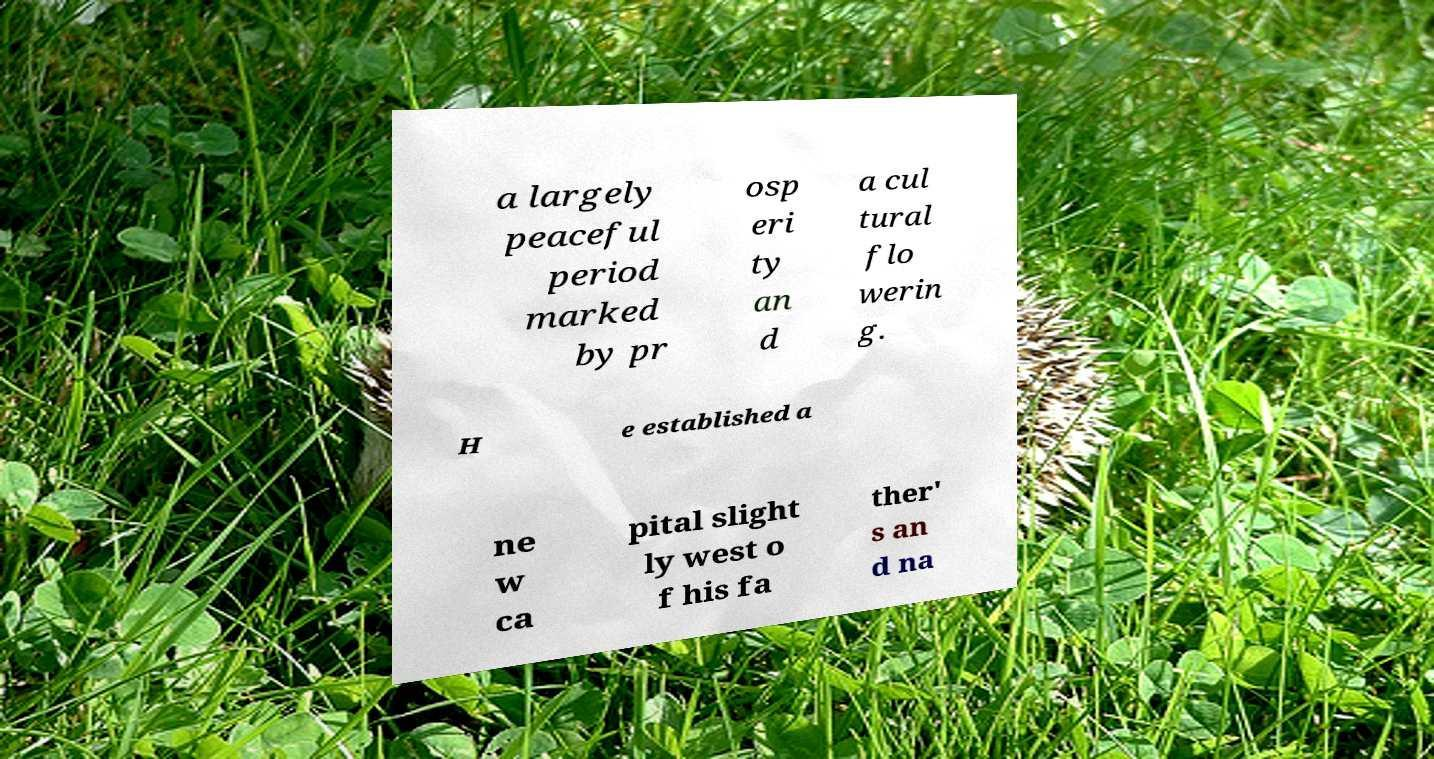Please read and relay the text visible in this image. What does it say? a largely peaceful period marked by pr osp eri ty an d a cul tural flo werin g. H e established a ne w ca pital slight ly west o f his fa ther' s an d na 